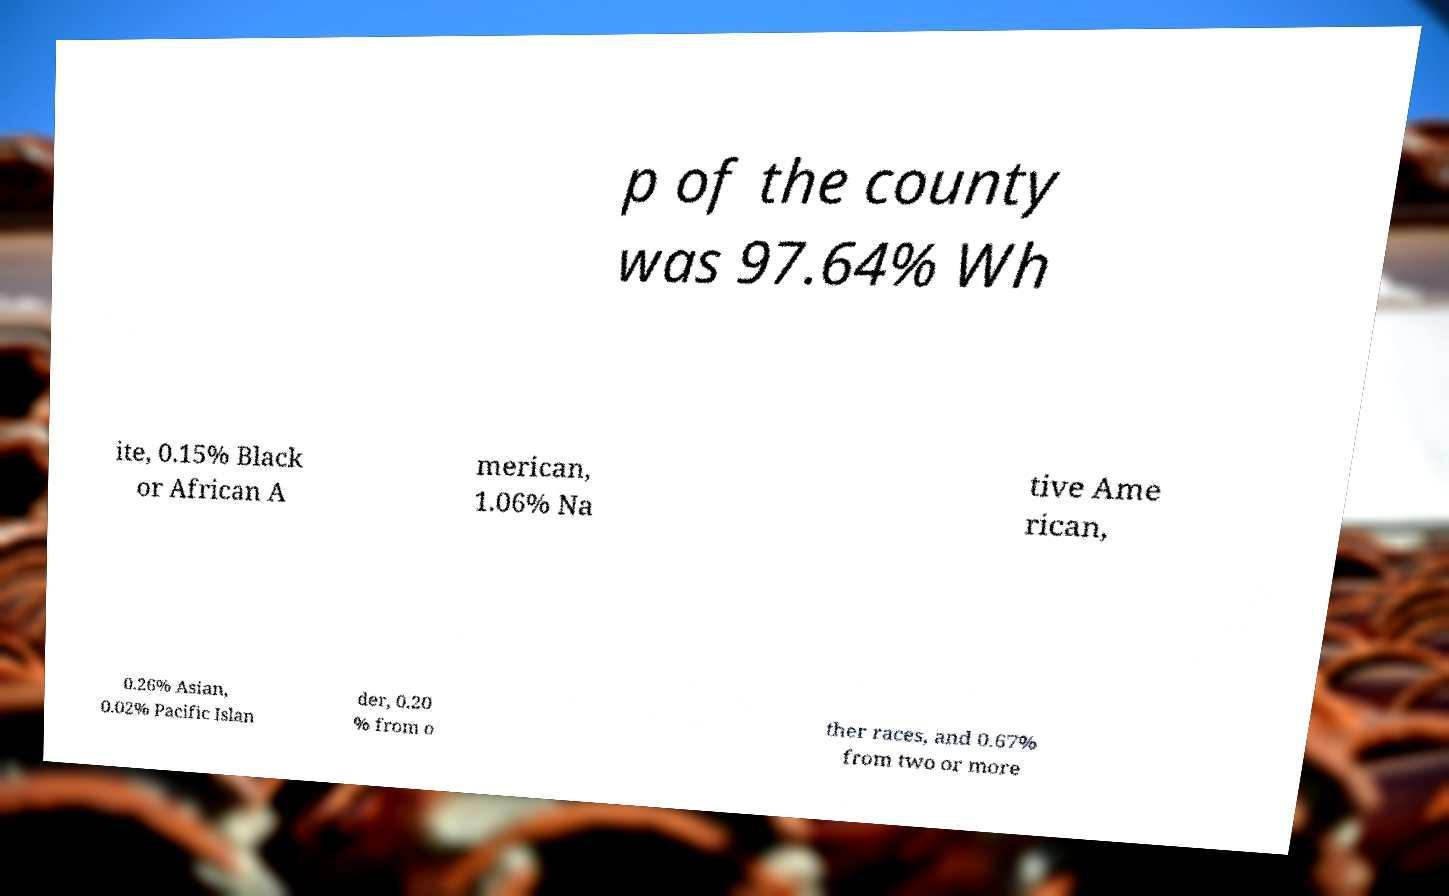Please read and relay the text visible in this image. What does it say? p of the county was 97.64% Wh ite, 0.15% Black or African A merican, 1.06% Na tive Ame rican, 0.26% Asian, 0.02% Pacific Islan der, 0.20 % from o ther races, and 0.67% from two or more 